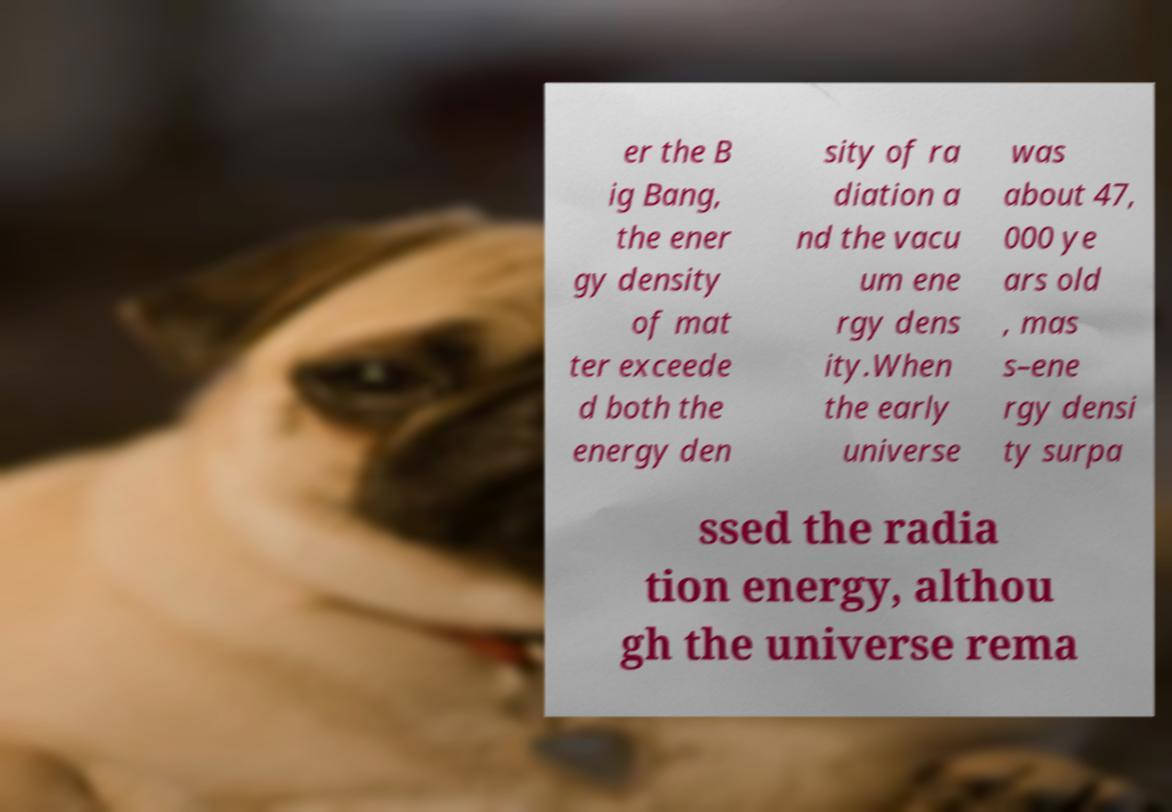What messages or text are displayed in this image? I need them in a readable, typed format. er the B ig Bang, the ener gy density of mat ter exceede d both the energy den sity of ra diation a nd the vacu um ene rgy dens ity.When the early universe was about 47, 000 ye ars old , mas s–ene rgy densi ty surpa ssed the radia tion energy, althou gh the universe rema 